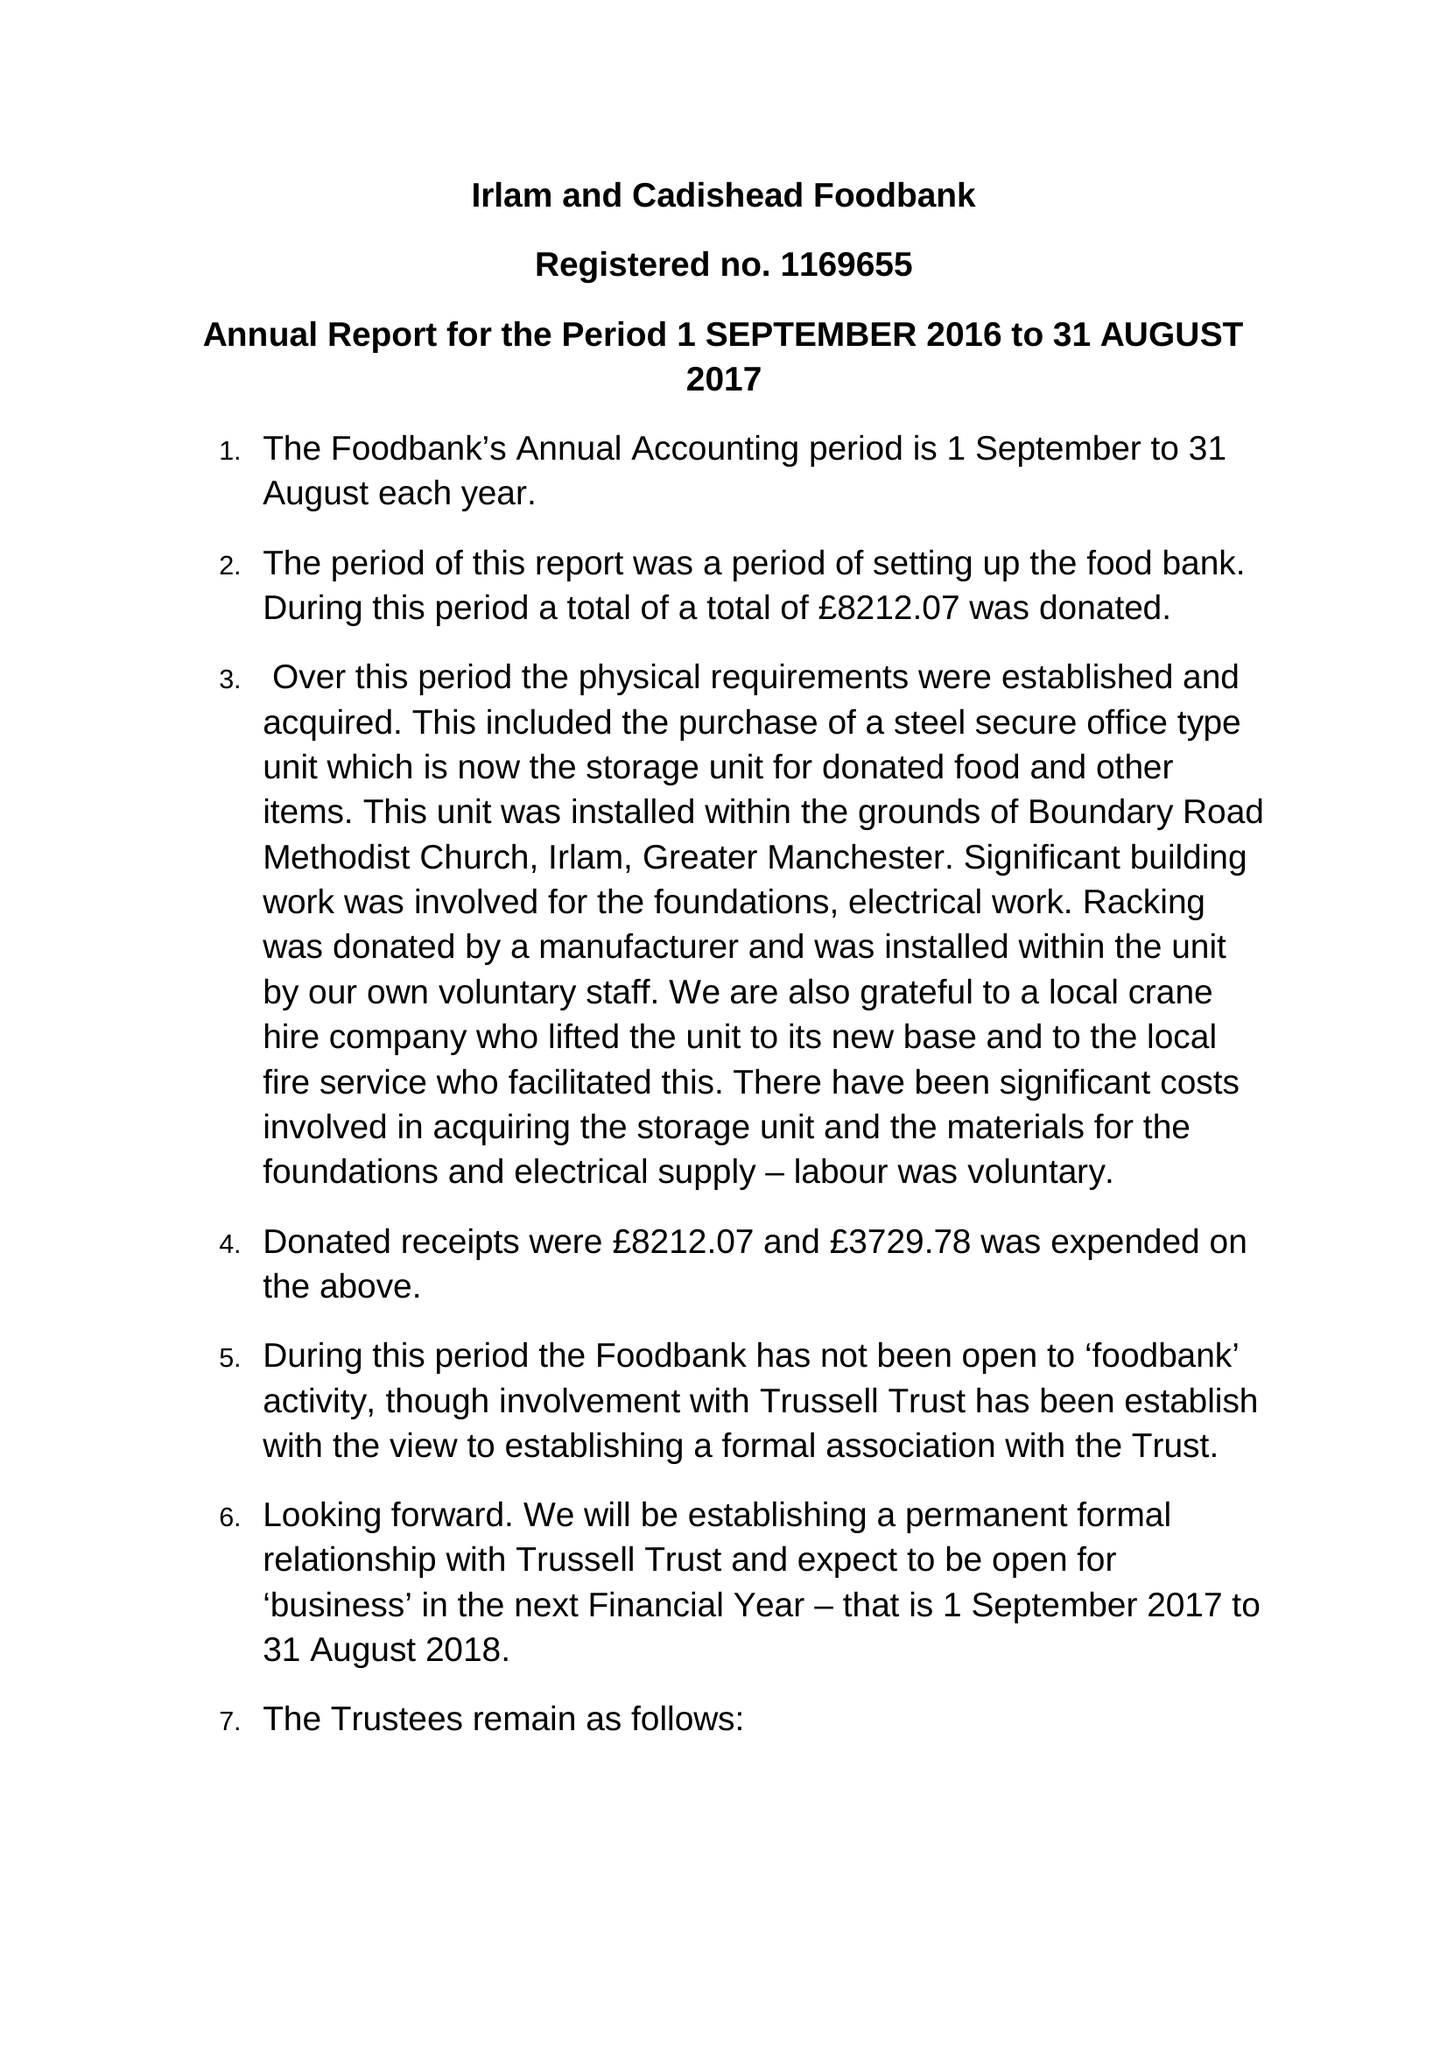What is the value for the address__postcode?
Answer the question using a single word or phrase. M44 6HD 